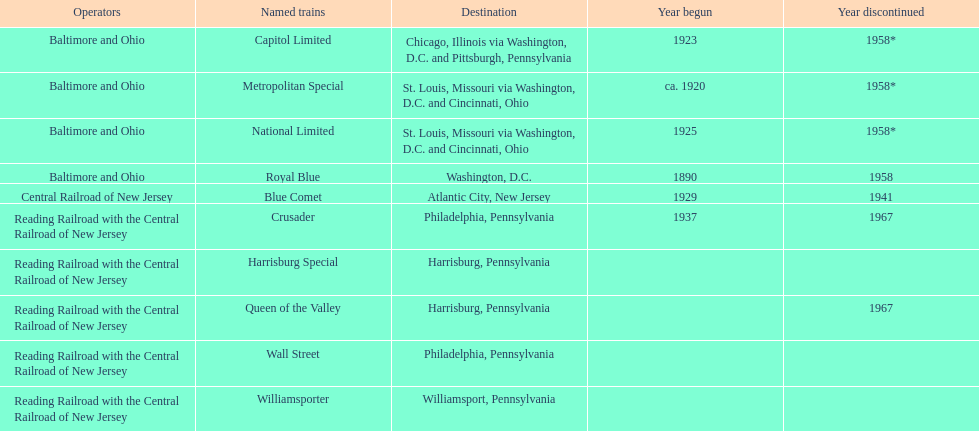How many years apart are the starting years of the royal blue and the crusader? 47. 